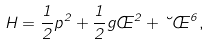Convert formula to latex. <formula><loc_0><loc_0><loc_500><loc_500>H = \frac { 1 } { 2 } p ^ { 2 } + \frac { 1 } { 2 } g \phi ^ { 2 } + \lambda \phi ^ { 6 } ,</formula> 